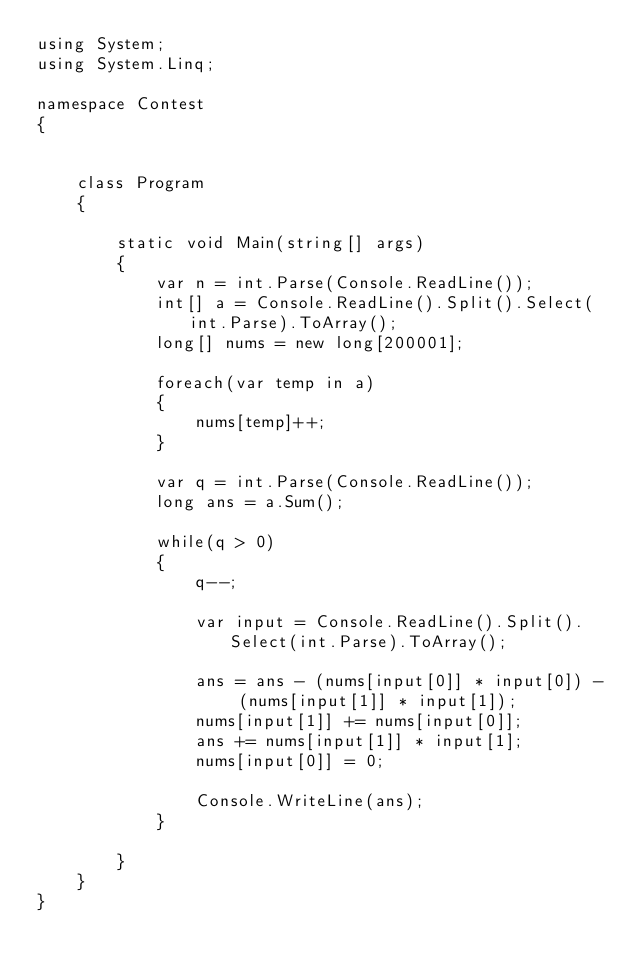Convert code to text. <code><loc_0><loc_0><loc_500><loc_500><_C#_>using System;
using System.Linq;

namespace Contest
{


    class Program
    {

        static void Main(string[] args)
        {
            var n = int.Parse(Console.ReadLine());
            int[] a = Console.ReadLine().Split().Select(int.Parse).ToArray();
            long[] nums = new long[200001];
            
            foreach(var temp in a)
            {
                nums[temp]++;
            }

            var q = int.Parse(Console.ReadLine());
            long ans = a.Sum();

            while(q > 0)
            {
                q--;

                var input = Console.ReadLine().Split().Select(int.Parse).ToArray();

                ans = ans - (nums[input[0]] * input[0]) - (nums[input[1]] * input[1]);
                nums[input[1]] += nums[input[0]];
                ans += nums[input[1]] * input[1];
                nums[input[0]] = 0;

                Console.WriteLine(ans);
            }

        }
    }
}</code> 